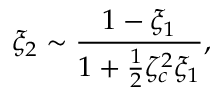<formula> <loc_0><loc_0><loc_500><loc_500>\xi _ { 2 } \sim \frac { 1 - \xi _ { 1 } } { 1 + \frac { 1 } { 2 } \zeta _ { c } ^ { 2 } \xi _ { 1 } } ,</formula> 